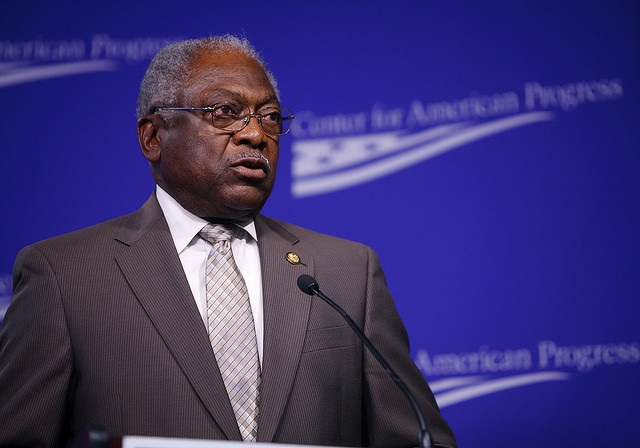Please extract the text content from this image. AMERICAN AMERICAN 